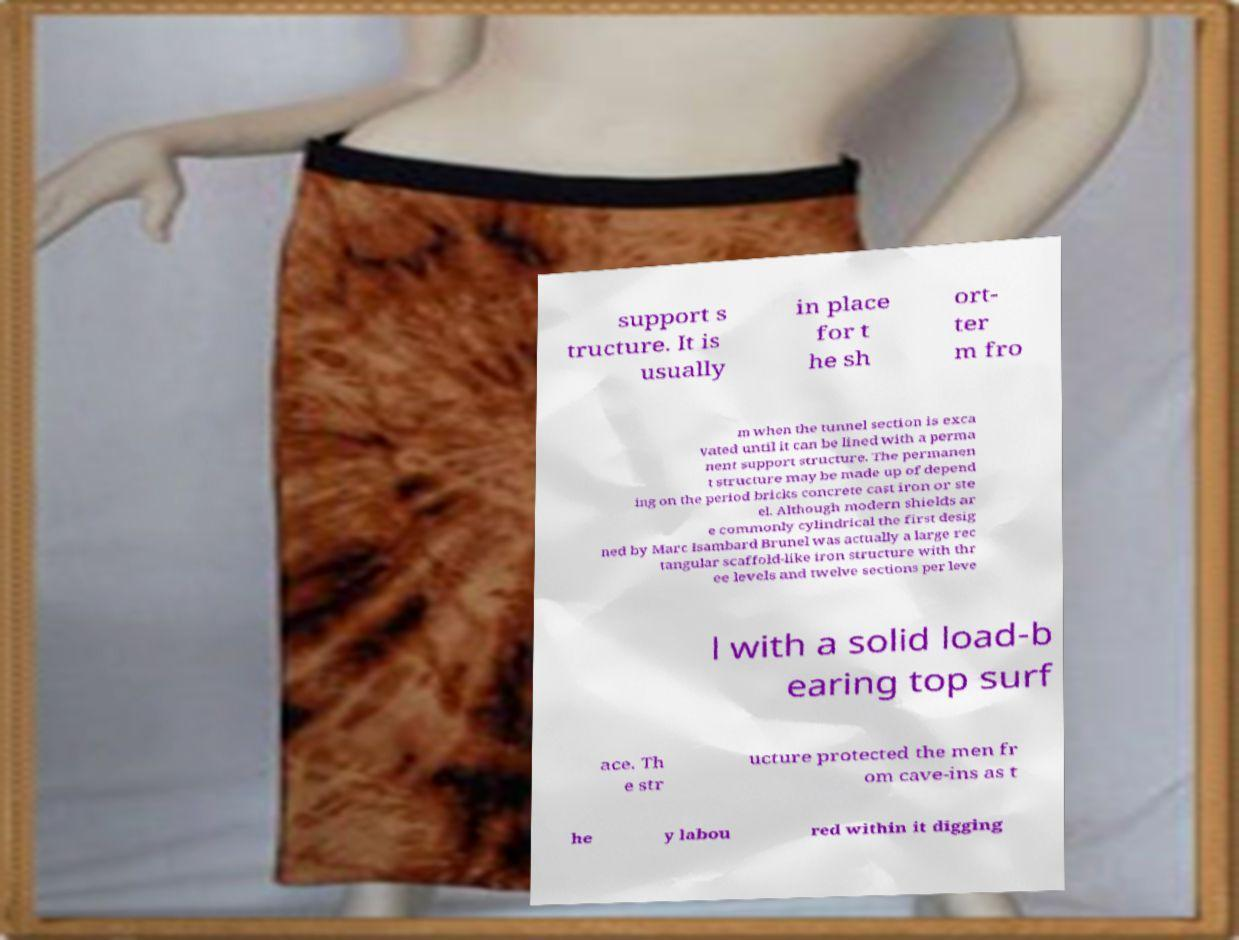There's text embedded in this image that I need extracted. Can you transcribe it verbatim? support s tructure. It is usually in place for t he sh ort- ter m fro m when the tunnel section is exca vated until it can be lined with a perma nent support structure. The permanen t structure may be made up of depend ing on the period bricks concrete cast iron or ste el. Although modern shields ar e commonly cylindrical the first desig ned by Marc Isambard Brunel was actually a large rec tangular scaffold-like iron structure with thr ee levels and twelve sections per leve l with a solid load-b earing top surf ace. Th e str ucture protected the men fr om cave-ins as t he y labou red within it digging 